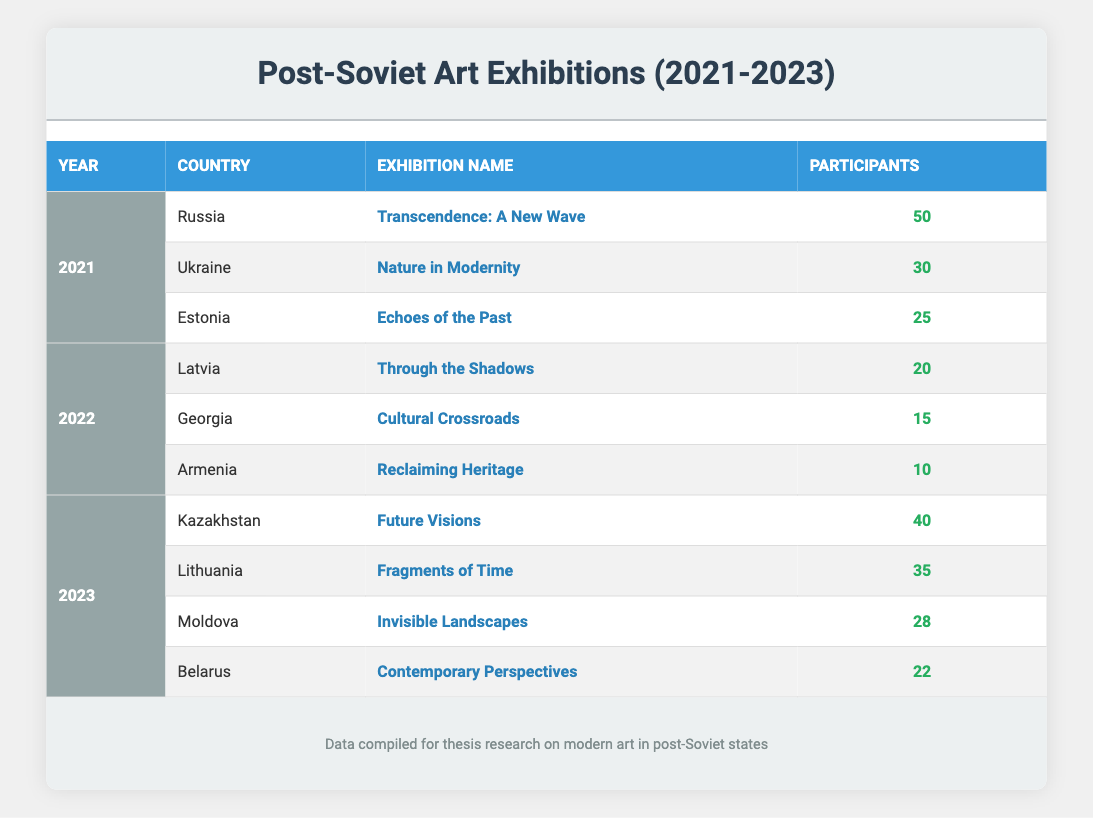What was the total number of participants from Armenia across all exhibitions? According to the table, Armenia had one exhibition in 2022 with 10 participants. Therefore, the total number of participants from Armenia is simply the value 10.
Answer: 10 In which year did Kazakhstan have its art exhibition, and what was the exhibition name? Kazakhstan's exhibition took place in 2023, and the event is titled "Future Visions." Both the year and the exhibition name can be directly identified from the table.
Answer: 2023, Future Visions Which country had the highest number of participants in 2021? The table shows that in 2021, Russia had 50 participants, Ukraine had 30, and Estonia had 25. Therefore, Russia is the country with the highest number of participants in that year.
Answer: Russia What is the average number of participants for the exhibitions held in 2022? In 2022, there were three exhibitions: Latvia (20 participants), Georgia (15 participants), and Armenia (10 participants). The sum is 20 + 15 + 10 = 45. To get the average, we divide by the number of exhibitions (3), which gives us 45/3 = 15.
Answer: 15 Did any exhibitions in 2023 have fewer participants than those in 2022? In 2023, the exhibitions had 40 (Kazakhstan), 35 (Lithuania), 28 (Moldova), and 22 (Belarus) participants. The 2022 exhibitions had 20 (Latvia), 15 (Georgia), and 10 (Armenia) participants. Since all exhibitions in 2023 had more participants than the maximum of 20 from 2022, the answer is no.
Answer: No What was the overall trend of participants in exhibitions from 2021 to 2023? By comparing the participant numbers, in 2021, the total was 105, in 2022, it was 45, and in 2023, it was 125. This shows a decline from 2021 to 2022, but an increase from 2022 to 2023. The overall trend indicates a peak in 2021 with a decline in 2022, followed by a rise in 2023.
Answer: Decline then increase Which exhibition had the least number of participants in the data? From the table, the exhibition "Reclaiming Heritage" in Armenia had the fewest participants, totaling just 10. This is identified by comparing the participant counts across all exhibitions.
Answer: Reclaiming Heritage How many countries exhibited art in 2021? The table shows that three countries had exhibitions in 2021: Russia, Ukraine, and Estonia. Counting these entries gives us a total of three countries exhibiting that year.
Answer: 3 Which year had the most exhibitions listed in the data? Analyzing the table, 2021 has three exhibitions, 2022 has three exhibitions, and 2023 has four exhibitions. Since 2023 has the highest number with four, that year stands out for the most exhibitions.
Answer: 2023 